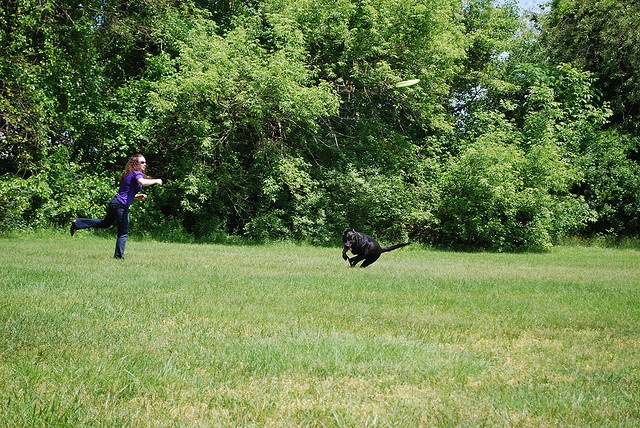Describe the objects in this image and their specific colors. I can see people in black, navy, white, and maroon tones, dog in black, gray, darkgreen, and darkgray tones, and frisbee in black, beige, khaki, lightgreen, and darkgreen tones in this image. 